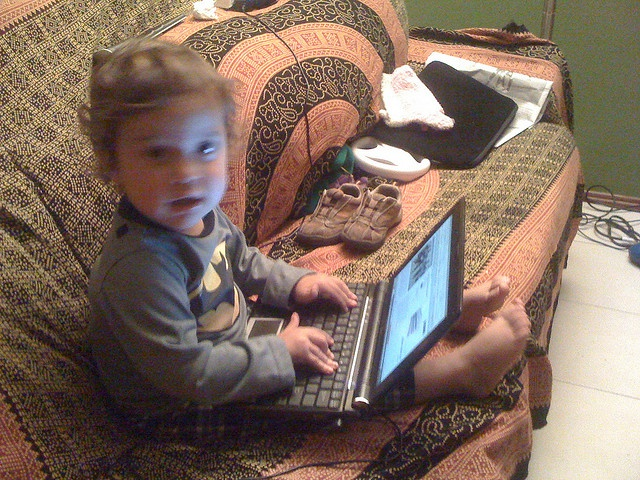Describe the objects in this image and their specific colors. I can see couch in black, salmon, maroon, and gray tones, people in lightpink, black, gray, maroon, and darkgray tones, and laptop in salmon, lightblue, gray, black, and darkgray tones in this image. 